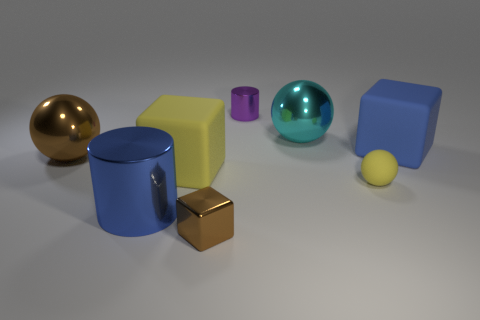Add 2 yellow cylinders. How many objects exist? 10 Subtract all big metallic balls. How many balls are left? 1 Subtract all purple cylinders. How many cylinders are left? 1 Subtract all cubes. How many objects are left? 5 Add 7 tiny brown things. How many tiny brown things exist? 8 Subtract 1 blue cylinders. How many objects are left? 7 Subtract 2 cylinders. How many cylinders are left? 0 Subtract all yellow cubes. Subtract all cyan spheres. How many cubes are left? 2 Subtract all cyan spheres. How many yellow blocks are left? 1 Subtract all big brown shiny things. Subtract all large balls. How many objects are left? 5 